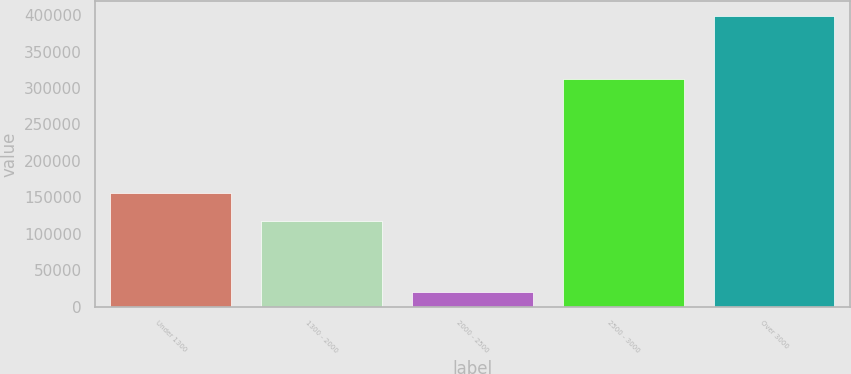Convert chart to OTSL. <chart><loc_0><loc_0><loc_500><loc_500><bar_chart><fcel>Under 1300<fcel>1300 - 2000<fcel>2000 - 2500<fcel>2500 - 3000<fcel>Over 3000<nl><fcel>155882<fcel>117931<fcel>19667<fcel>311751<fcel>399175<nl></chart> 